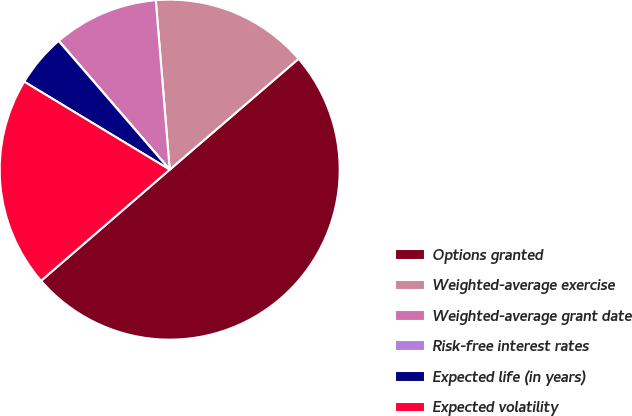<chart> <loc_0><loc_0><loc_500><loc_500><pie_chart><fcel>Options granted<fcel>Weighted-average exercise<fcel>Weighted-average grant date<fcel>Risk-free interest rates<fcel>Expected life (in years)<fcel>Expected volatility<nl><fcel>49.97%<fcel>15.0%<fcel>10.01%<fcel>0.02%<fcel>5.01%<fcel>20.0%<nl></chart> 